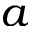<formula> <loc_0><loc_0><loc_500><loc_500>a</formula> 